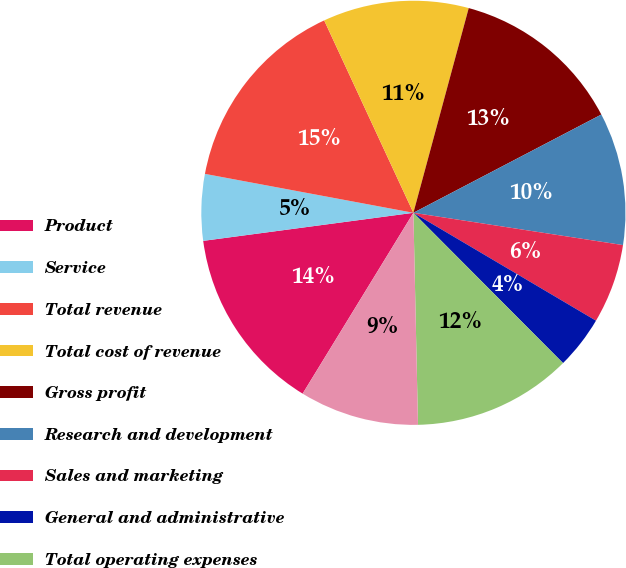Convert chart. <chart><loc_0><loc_0><loc_500><loc_500><pie_chart><fcel>Product<fcel>Service<fcel>Total revenue<fcel>Total cost of revenue<fcel>Gross profit<fcel>Research and development<fcel>Sales and marketing<fcel>General and administrative<fcel>Total operating expenses<fcel>Income from operations<nl><fcel>14.14%<fcel>5.05%<fcel>15.15%<fcel>11.11%<fcel>13.13%<fcel>10.1%<fcel>6.06%<fcel>4.04%<fcel>12.12%<fcel>9.09%<nl></chart> 